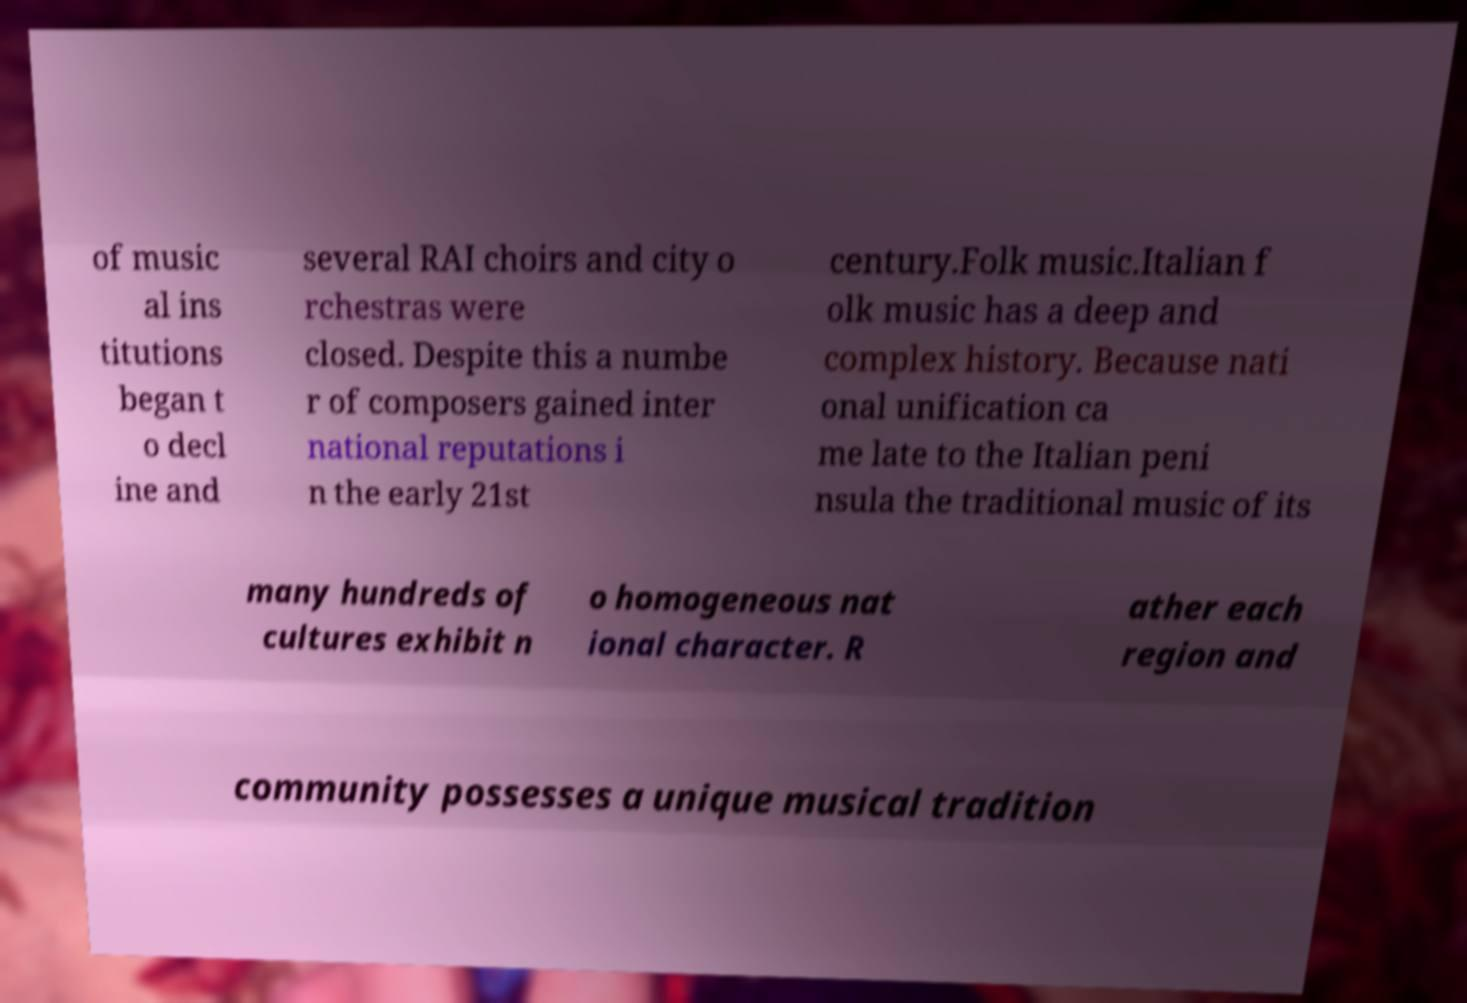Please read and relay the text visible in this image. What does it say? of music al ins titutions began t o decl ine and several RAI choirs and city o rchestras were closed. Despite this a numbe r of composers gained inter national reputations i n the early 21st century.Folk music.Italian f olk music has a deep and complex history. Because nati onal unification ca me late to the Italian peni nsula the traditional music of its many hundreds of cultures exhibit n o homogeneous nat ional character. R ather each region and community possesses a unique musical tradition 